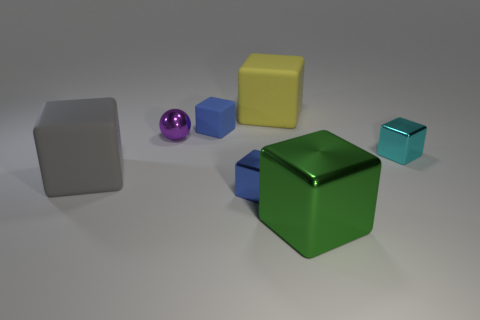What is the color of the ball?
Give a very brief answer. Purple. How many large things are either cyan cylinders or cyan objects?
Make the answer very short. 0. There is a tiny metal object that is behind the small cyan shiny thing; is its color the same as the metal block left of the yellow object?
Keep it short and to the point. No. How many other things are there of the same color as the tiny matte thing?
Offer a very short reply. 1. There is a matte object that is to the right of the blue rubber block; what shape is it?
Your response must be concise. Cube. Is the number of large green things less than the number of large cyan rubber balls?
Your response must be concise. No. Does the object that is to the right of the green shiny block have the same material as the big gray cube?
Ensure brevity in your answer.  No. Are there any other things that are the same size as the cyan shiny object?
Provide a short and direct response. Yes. There is a large yellow rubber block; are there any tiny purple objects behind it?
Provide a succinct answer. No. There is a rubber object on the left side of the small thing that is to the left of the small blue block behind the small purple object; what color is it?
Offer a terse response. Gray. 